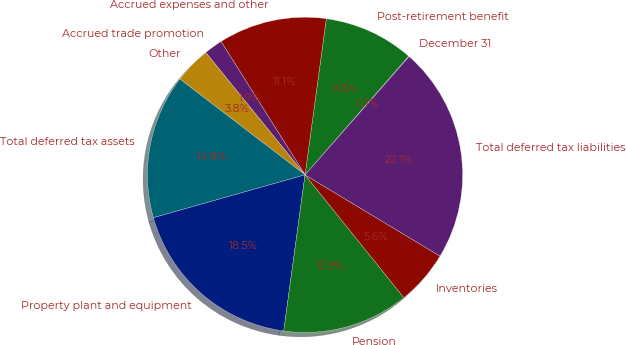<chart> <loc_0><loc_0><loc_500><loc_500><pie_chart><fcel>December 31<fcel>Post-retirement benefit<fcel>Accrued expenses and other<fcel>Accrued trade promotion<fcel>Other<fcel>Total deferred tax assets<fcel>Property plant and equipment<fcel>Pension<fcel>Inventories<fcel>Total deferred tax liabilities<nl><fcel>0.07%<fcel>9.26%<fcel>11.1%<fcel>1.91%<fcel>3.75%<fcel>14.78%<fcel>18.46%<fcel>12.94%<fcel>5.59%<fcel>22.14%<nl></chart> 